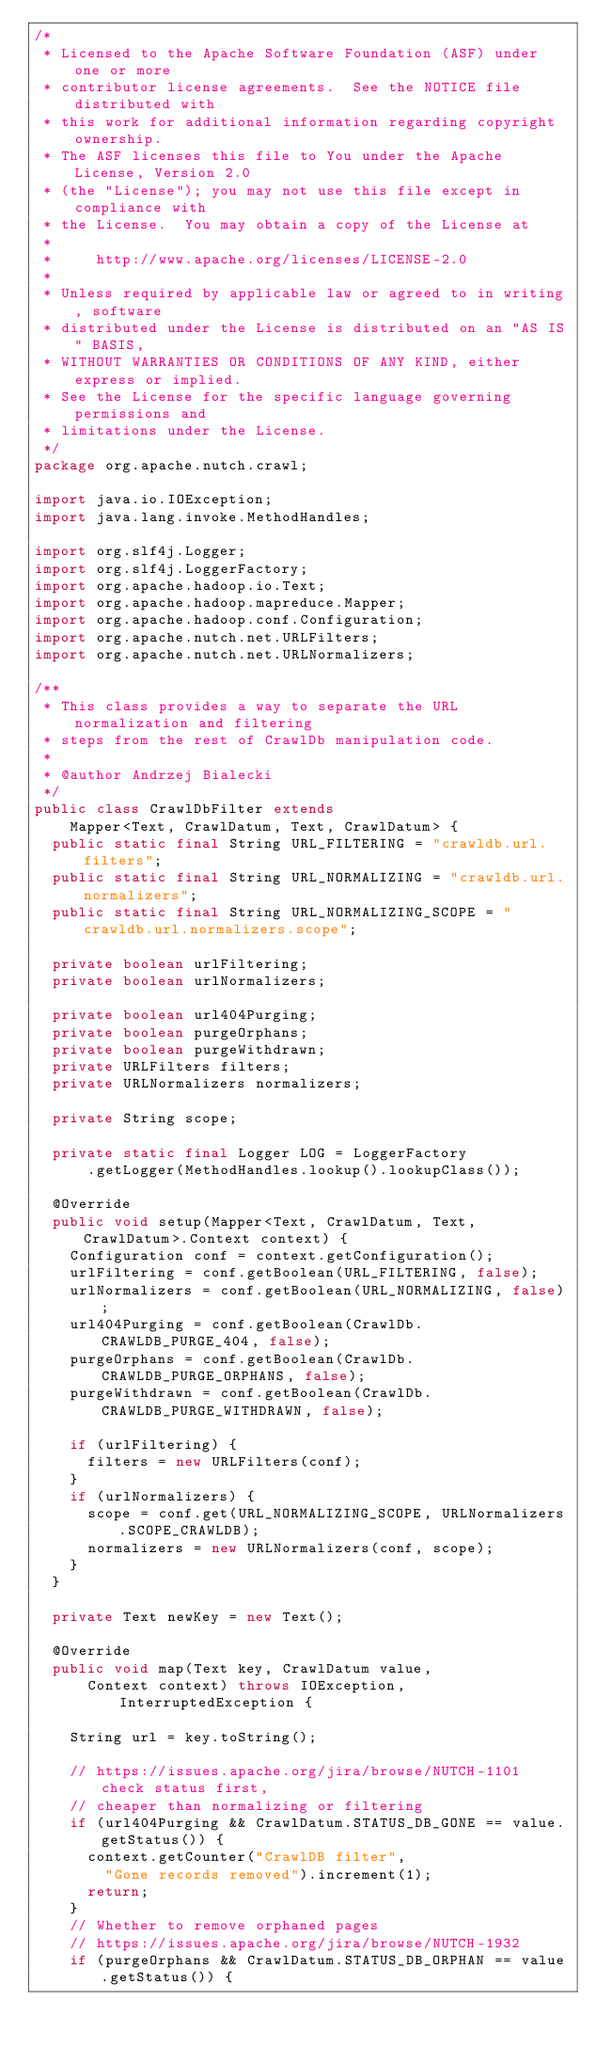Convert code to text. <code><loc_0><loc_0><loc_500><loc_500><_Java_>/*
 * Licensed to the Apache Software Foundation (ASF) under one or more
 * contributor license agreements.  See the NOTICE file distributed with
 * this work for additional information regarding copyright ownership.
 * The ASF licenses this file to You under the Apache License, Version 2.0
 * (the "License"); you may not use this file except in compliance with
 * the License.  You may obtain a copy of the License at
 *
 *     http://www.apache.org/licenses/LICENSE-2.0
 *
 * Unless required by applicable law or agreed to in writing, software
 * distributed under the License is distributed on an "AS IS" BASIS,
 * WITHOUT WARRANTIES OR CONDITIONS OF ANY KIND, either express or implied.
 * See the License for the specific language governing permissions and
 * limitations under the License.
 */
package org.apache.nutch.crawl;

import java.io.IOException;
import java.lang.invoke.MethodHandles;

import org.slf4j.Logger;
import org.slf4j.LoggerFactory;
import org.apache.hadoop.io.Text;
import org.apache.hadoop.mapreduce.Mapper;
import org.apache.hadoop.conf.Configuration;
import org.apache.nutch.net.URLFilters;
import org.apache.nutch.net.URLNormalizers;

/**
 * This class provides a way to separate the URL normalization and filtering
 * steps from the rest of CrawlDb manipulation code.
 * 
 * @author Andrzej Bialecki
 */
public class CrawlDbFilter extends
    Mapper<Text, CrawlDatum, Text, CrawlDatum> {
  public static final String URL_FILTERING = "crawldb.url.filters";
  public static final String URL_NORMALIZING = "crawldb.url.normalizers";
  public static final String URL_NORMALIZING_SCOPE = "crawldb.url.normalizers.scope";

  private boolean urlFiltering;
  private boolean urlNormalizers;

  private boolean url404Purging;
  private boolean purgeOrphans;
  private boolean purgeWithdrawn;
  private URLFilters filters;
  private URLNormalizers normalizers;

  private String scope;

  private static final Logger LOG = LoggerFactory
      .getLogger(MethodHandles.lookup().lookupClass());

  @Override
  public void setup(Mapper<Text, CrawlDatum, Text, CrawlDatum>.Context context) {
    Configuration conf = context.getConfiguration();
    urlFiltering = conf.getBoolean(URL_FILTERING, false);
    urlNormalizers = conf.getBoolean(URL_NORMALIZING, false);
    url404Purging = conf.getBoolean(CrawlDb.CRAWLDB_PURGE_404, false);
    purgeOrphans = conf.getBoolean(CrawlDb.CRAWLDB_PURGE_ORPHANS, false);
    purgeWithdrawn = conf.getBoolean(CrawlDb.CRAWLDB_PURGE_WITHDRAWN, false);

    if (urlFiltering) {
      filters = new URLFilters(conf);
    }
    if (urlNormalizers) {
      scope = conf.get(URL_NORMALIZING_SCOPE, URLNormalizers.SCOPE_CRAWLDB);
      normalizers = new URLNormalizers(conf, scope);
    }
  }

  private Text newKey = new Text();

  @Override
  public void map(Text key, CrawlDatum value,
      Context context) throws IOException, InterruptedException {

    String url = key.toString();

    // https://issues.apache.org/jira/browse/NUTCH-1101 check status first,
    // cheaper than normalizing or filtering
    if (url404Purging && CrawlDatum.STATUS_DB_GONE == value.getStatus()) {
      context.getCounter("CrawlDB filter",
        "Gone records removed").increment(1);
      return;
    }
    // Whether to remove orphaned pages
    // https://issues.apache.org/jira/browse/NUTCH-1932
    if (purgeOrphans && CrawlDatum.STATUS_DB_ORPHAN == value.getStatus()) {</code> 